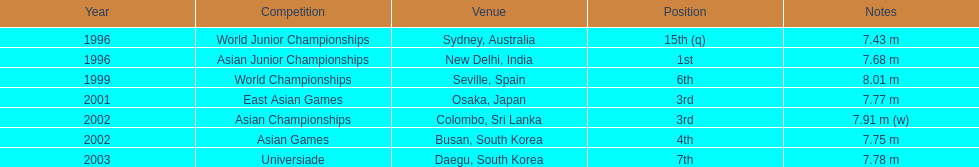What was the only competition where this competitor achieved 1st place? Asian Junior Championships. 